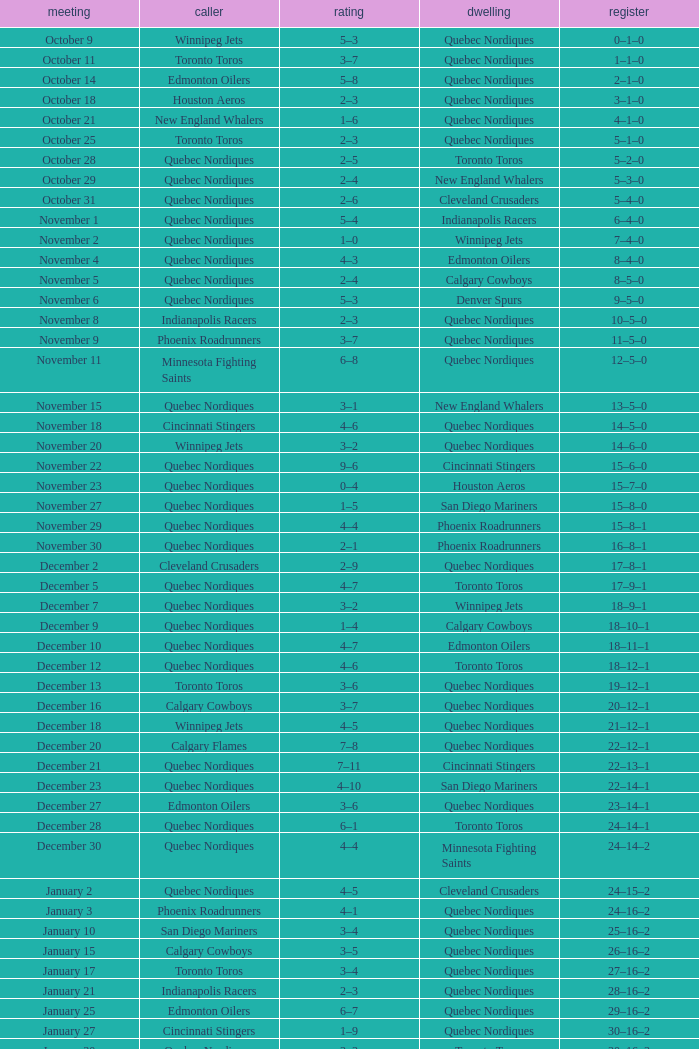What was the score of the game when the record was 39–21–4? 5–4. 